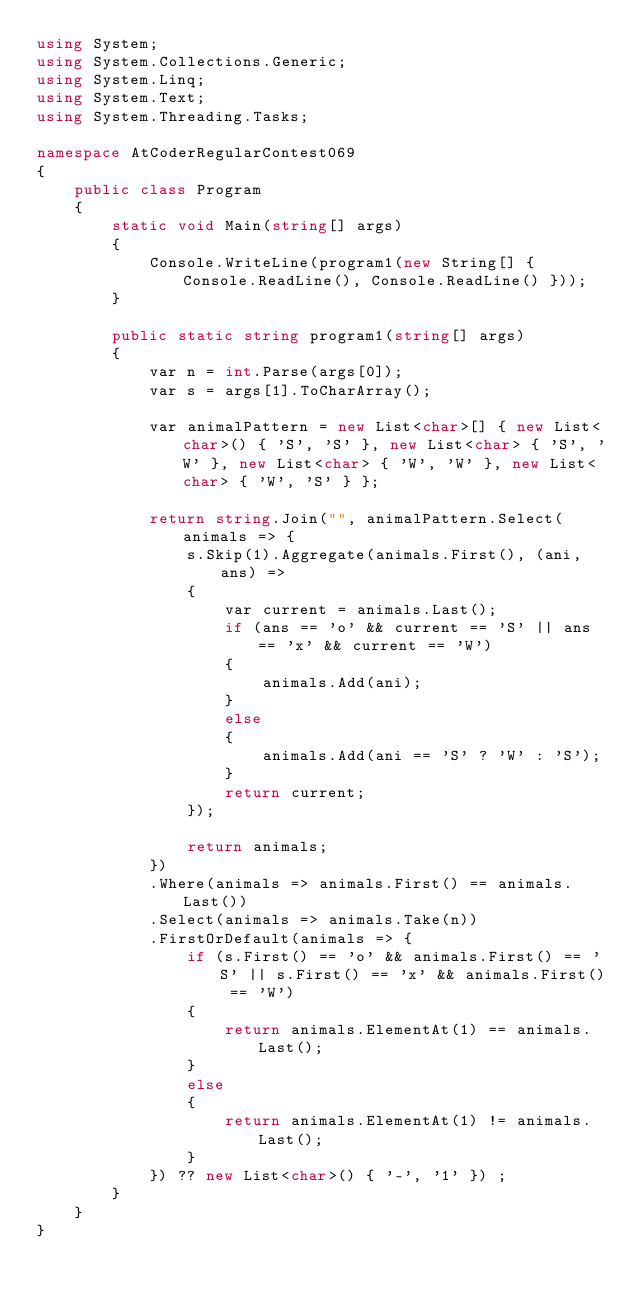<code> <loc_0><loc_0><loc_500><loc_500><_C#_>using System;
using System.Collections.Generic;
using System.Linq;
using System.Text;
using System.Threading.Tasks;

namespace AtCoderRegularContest069
{
    public class Program
    {
        static void Main(string[] args)
        {
            Console.WriteLine(program1(new String[] { Console.ReadLine(), Console.ReadLine() }));
        }

        public static string program1(string[] args)
        {
            var n = int.Parse(args[0]);
            var s = args[1].ToCharArray();

            var animalPattern = new List<char>[] { new List<char>() { 'S', 'S' }, new List<char> { 'S', 'W' }, new List<char> { 'W', 'W' }, new List<char> { 'W', 'S' } };

            return string.Join("", animalPattern.Select(animals => {
                s.Skip(1).Aggregate(animals.First(), (ani, ans) =>
                {
                    var current = animals.Last();
                    if (ans == 'o' && current == 'S' || ans == 'x' && current == 'W')
                    {
                        animals.Add(ani);
                    }
                    else
                    {
                        animals.Add(ani == 'S' ? 'W' : 'S');
                    }
                    return current;
                });

                return animals;
            })
            .Where(animals => animals.First() == animals.Last())
            .Select(animals => animals.Take(n))
            .FirstOrDefault(animals => {
                if (s.First() == 'o' && animals.First() == 'S' || s.First() == 'x' && animals.First() == 'W')
                {
                    return animals.ElementAt(1) == animals.Last();
                }
                else
                {
                    return animals.ElementAt(1) != animals.Last();
                }
            }) ?? new List<char>() { '-', '1' }) ;
        }
    }
}
</code> 